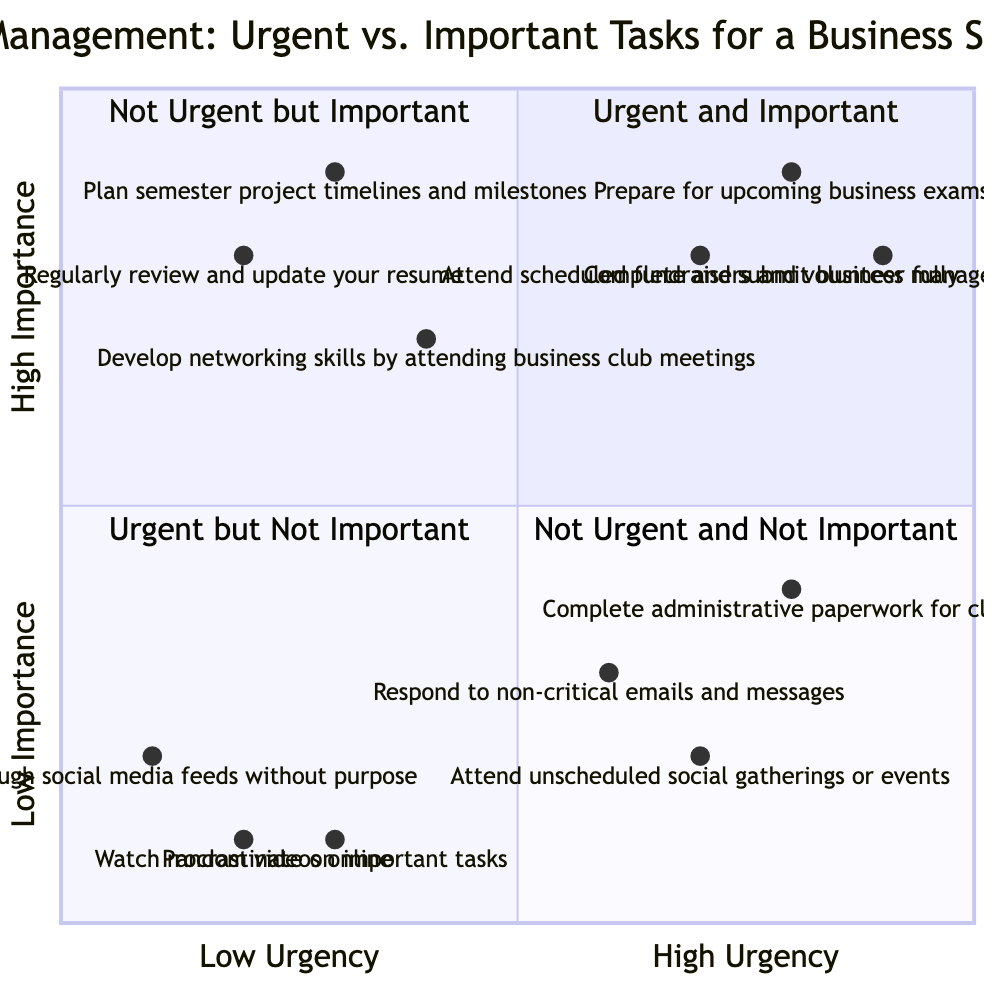What tasks are in the "Urgent and Important" quadrant? The "Urgent and Important" quadrant contains three tasks: "Prepare for upcoming business exams," "Complete and submit business management assignments," and "Attend scheduled fundraisers and volunteer fully."
Answer: Prepare for upcoming business exams, Complete and submit business management assignments, Attend scheduled fundraisers and volunteer fully How many tasks are listed in the "Not Urgent but Important" quadrant? The "Not Urgent but Important" quadrant lists three tasks: "Plan semester project timelines and milestones," "Regularly review and update your resume," and "Develop networking skills by attending business club meetings." Therefore, the total number of tasks is three.
Answer: 3 Which task has the lowest importance rating in the "Not Urgent and Not Important" quadrant? The "Not Urgent and Not Important" quadrant has three tasks. Among these, "Watch random videos online" has the lowest importance rating of 0.1.
Answer: Watch random videos online Is "Respond to non-critical emails and messages" more urgent or less urgent than "Complete administrative paperwork for classes"? "Respond to non-critical emails and messages" has an urgency rating of 0.6, while "Complete administrative paperwork for classes" has a rating of 0.8. Since 0.6 is less than 0.8, it is clear that responding to emails is less urgent than completing paperwork.
Answer: Less urgent Which task is rated more important: "Attend unscheduled social gatherings or events" or "Scroll through social media feeds without purpose"? The importance rating of "Attend unscheduled social gatherings or events" is 0.2 while "Scroll through social media feeds without purpose" is rated at 0.2 as well. It indicates that both tasks have the same low importance level of 0.2.
Answer: They are equally important What is the significance of the task "Develop networking skills by attending business club meetings" in the quadrants? This task appears in the "Not Urgent but Important" quadrant, highlighting that while it is not time-sensitive, it holds significant importance for personal and career development for a business student.
Answer: Important for development Which quadrant contains tasks with the highest urgency ratings? Both the "Urgent and Important" and "Urgent but Not Important" quadrants contain tasks with high urgency ratings. However, tasks in the "Urgent and Important" quadrant have higher overall urgency ratings than those in the "Urgent but Not Important" quadrant, as seen with tasks rated above 0.7 in the former.
Answer: Urgent and Important What is the primary focus of tasks in the "Not Urgent but Important" quadrant? The tasks in the "Not Urgent but Important" quadrant focus on personal and professional development, such as planning timelines, updating resumes, and networking, which are essential but do not require immediate action.
Answer: Personal and professional development Which task represents procrastination and where is it located in the quadrants? "Procrastinate on important tasks" represents procrastination and is located in the "Not Urgent and Not Important" quadrant, indicating it has low urgency and low importance.
Answer: Not Urgent and Not Important quadrant 